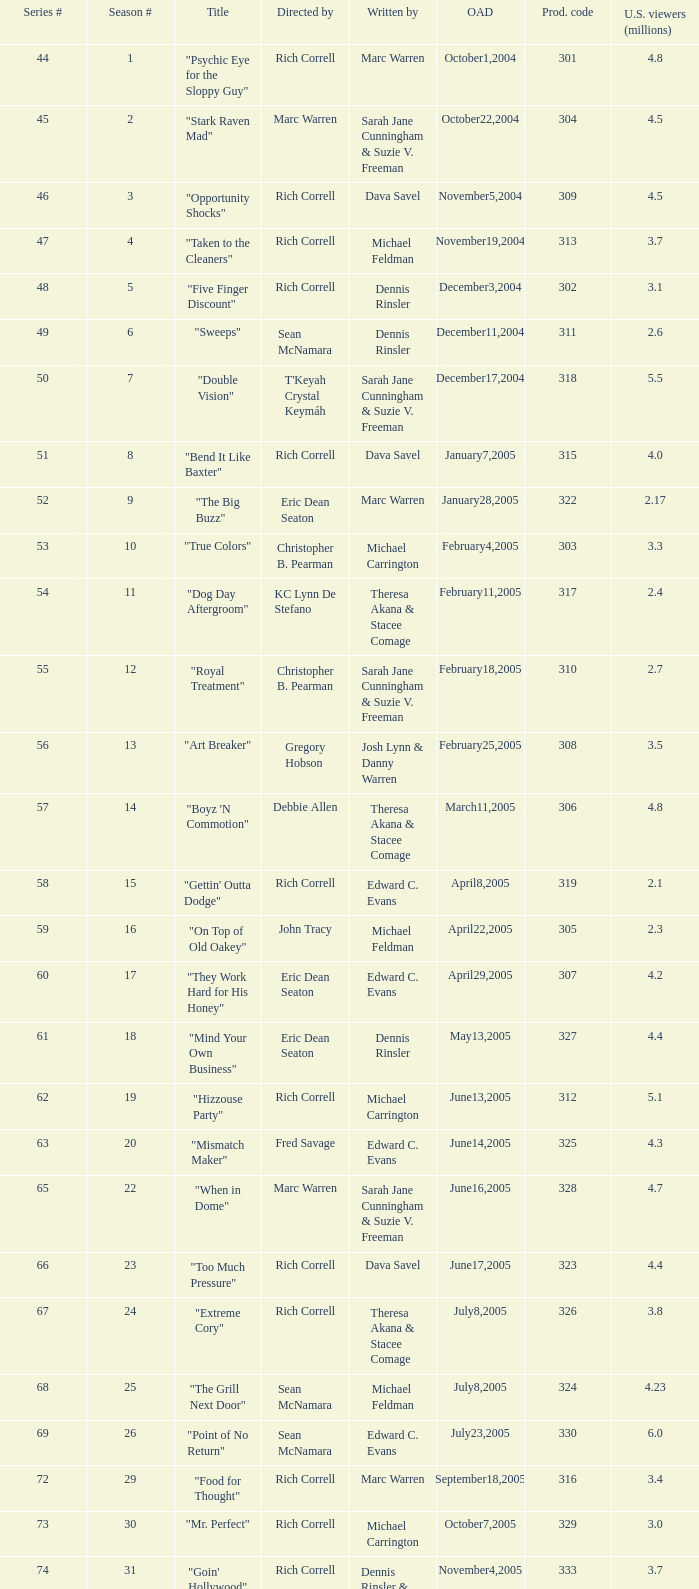What is the title of the episode directed by Rich Correll and written by Dennis Rinsler? "Five Finger Discount". 